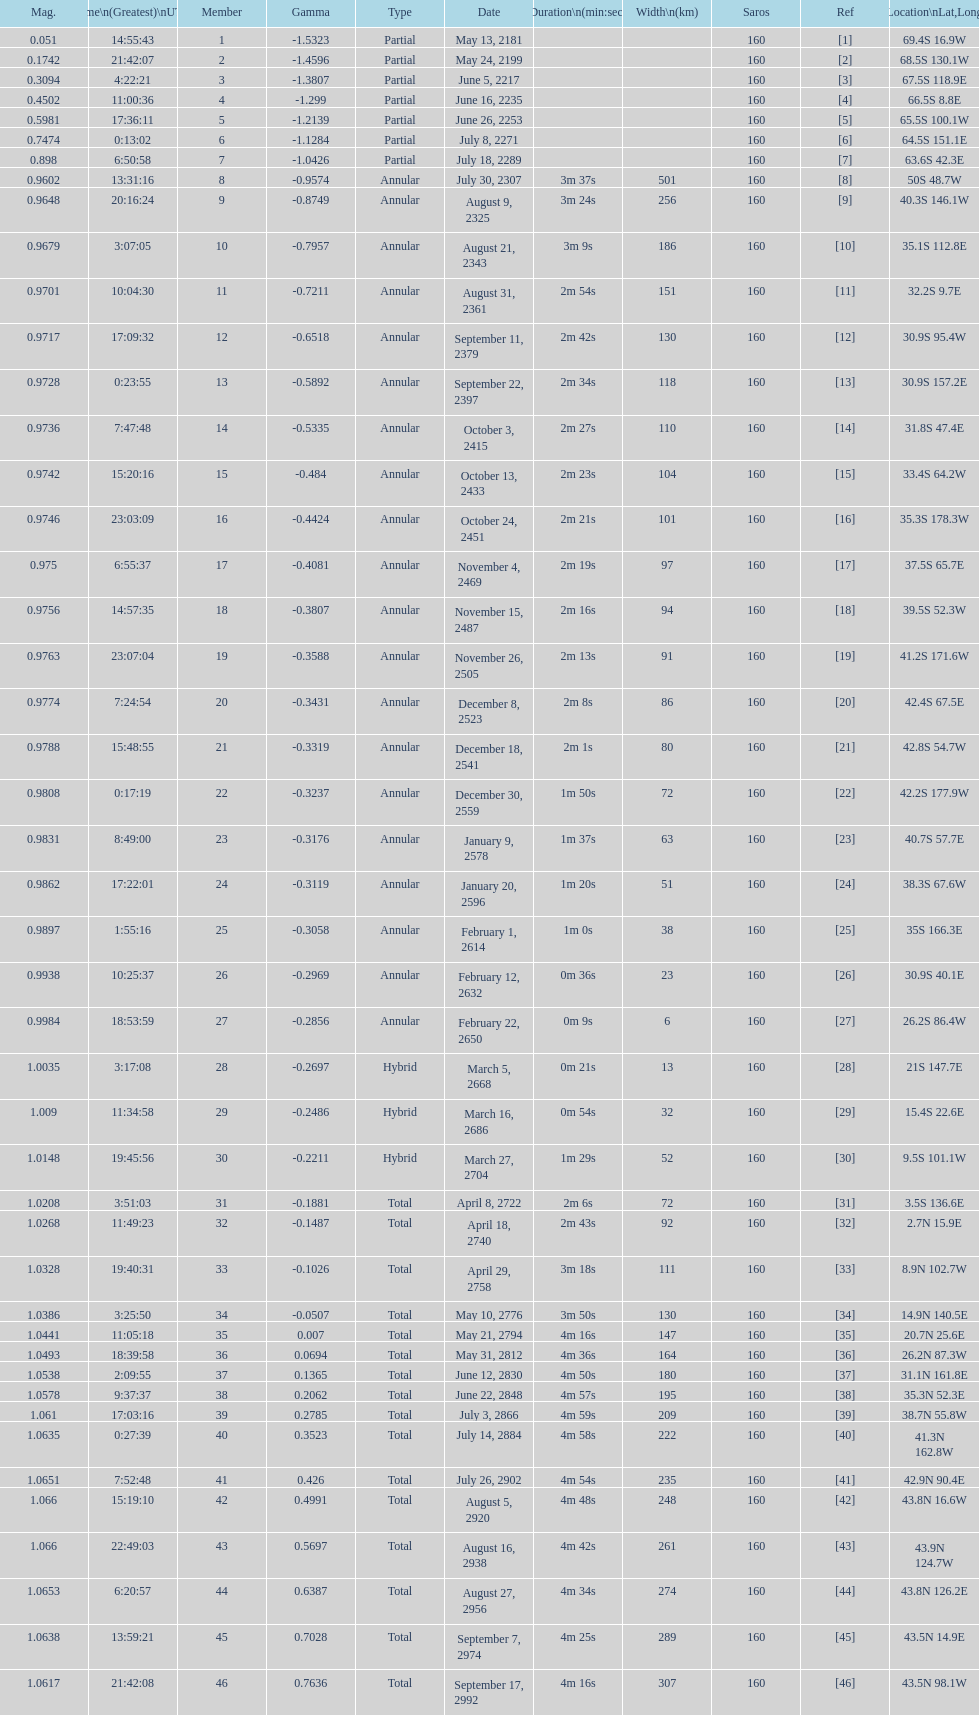Name a member number with a latitude above 60 s. 1. 